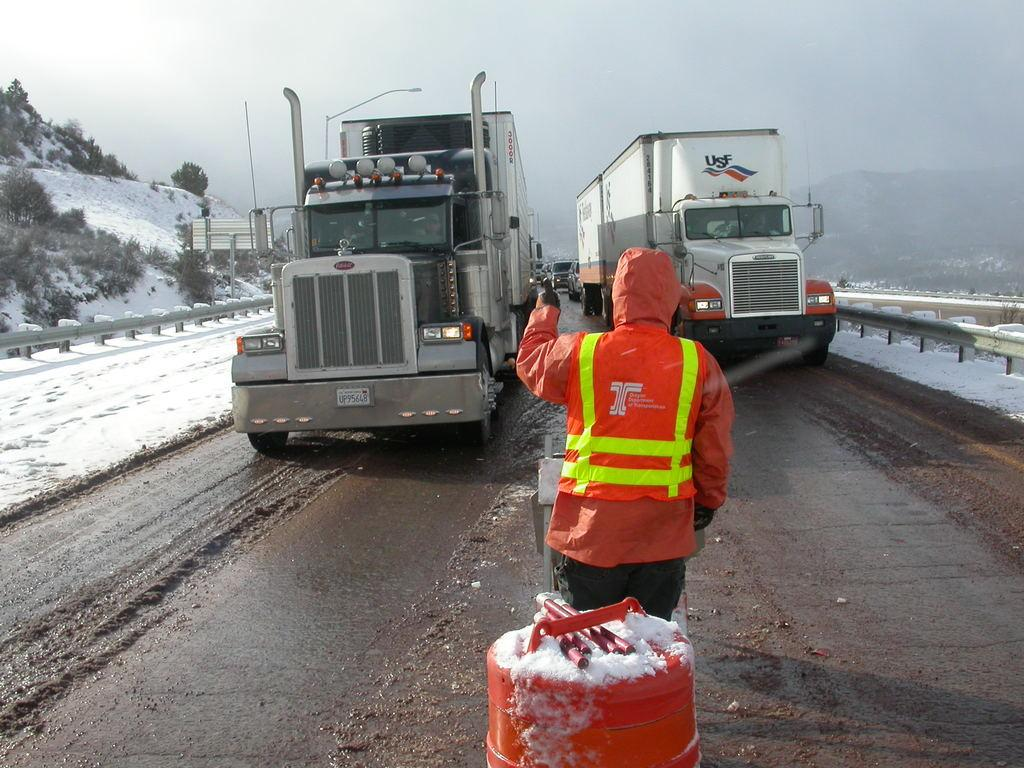What type of vehicles can be seen on the road in the image? There are trucks on the road in the image. Can you describe the person in the image? There is a person standing in the image. What is the color of the object on the road? There is a red color object on the road. What can be seen in the background of the image? There are trees, snow, a fence, and the sky visible in the background of the image. Where is the bedroom located in the image? There is no bedroom present in the image. What type of sport is being played in the image? There is no sport or volleyball present in the image. 